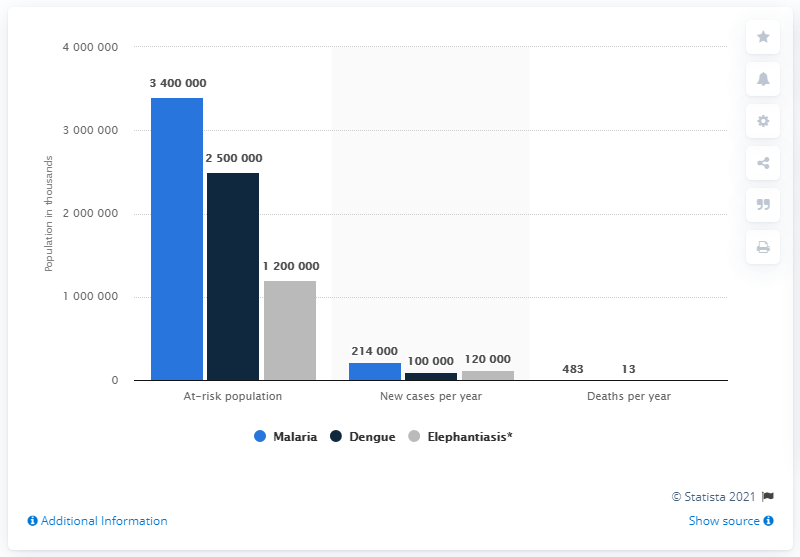Outline some significant characteristics in this image. In 2015, there were approximately 340,000 individuals at risk of contracting malaria. 